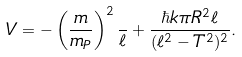Convert formula to latex. <formula><loc_0><loc_0><loc_500><loc_500>V = - \left ( { \frac { m } { m _ { P } } } \right ) ^ { 2 } { \frac { } { \ell } } + { \frac { \hbar { k } \pi R ^ { 2 } \ell } { ( \ell ^ { 2 } - T ^ { 2 } ) ^ { 2 } } } .</formula> 